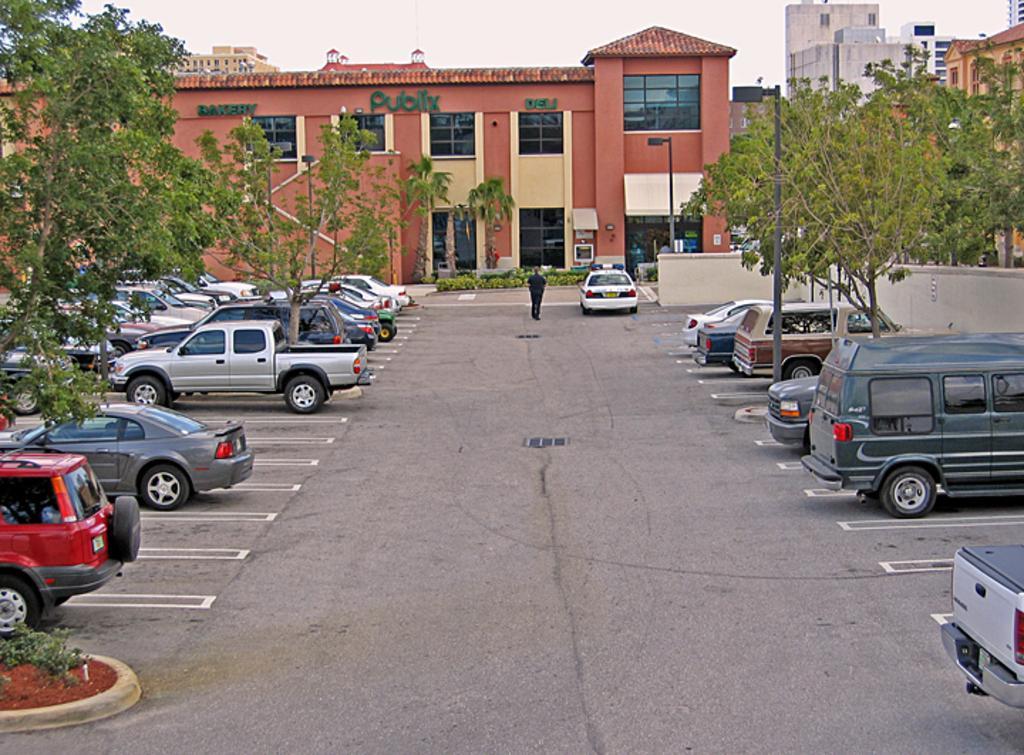Could you give a brief overview of what you see in this image? In this picture I can see the road in front on which there are number of cars and I see number of trees. In the middle of this picture I see number of buildings and I see a person who is standing and I see few poles and I see something is written on the building which is in the center and I see that it is white color in the background. 